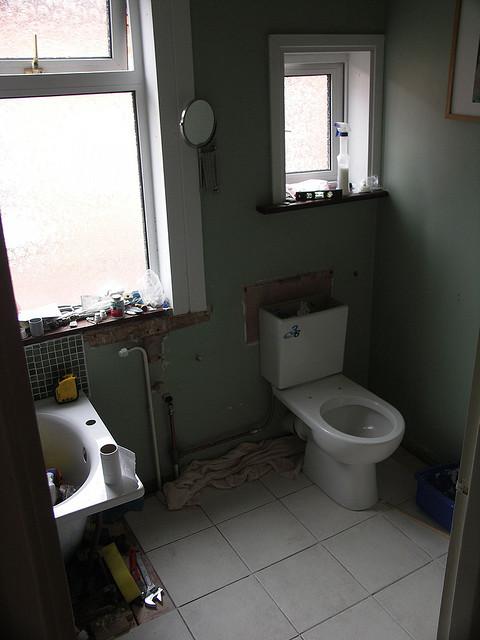What kind of flooring is in the bathroom?
Give a very brief answer. Tile. What room is this?
Give a very brief answer. Bathroom. Is the bathroom window closed?
Keep it brief. Yes. Does this room appear to be clean?
Write a very short answer. No. What color is the floor?
Keep it brief. White. Can you see clearly through the window?
Short answer required. No. 